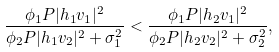Convert formula to latex. <formula><loc_0><loc_0><loc_500><loc_500>\frac { \phi _ { 1 } P | h _ { 1 } v _ { 1 } | ^ { 2 } } { \phi _ { 2 } P | h _ { 1 } v _ { 2 } | ^ { 2 } + \sigma _ { 1 } ^ { 2 } } < \frac { \phi _ { 1 } P | h _ { 2 } v _ { 1 } | ^ { 2 } } { \phi _ { 2 } P | h _ { 2 } v _ { 2 } | ^ { 2 } + \sigma _ { 2 } ^ { 2 } } ,</formula> 